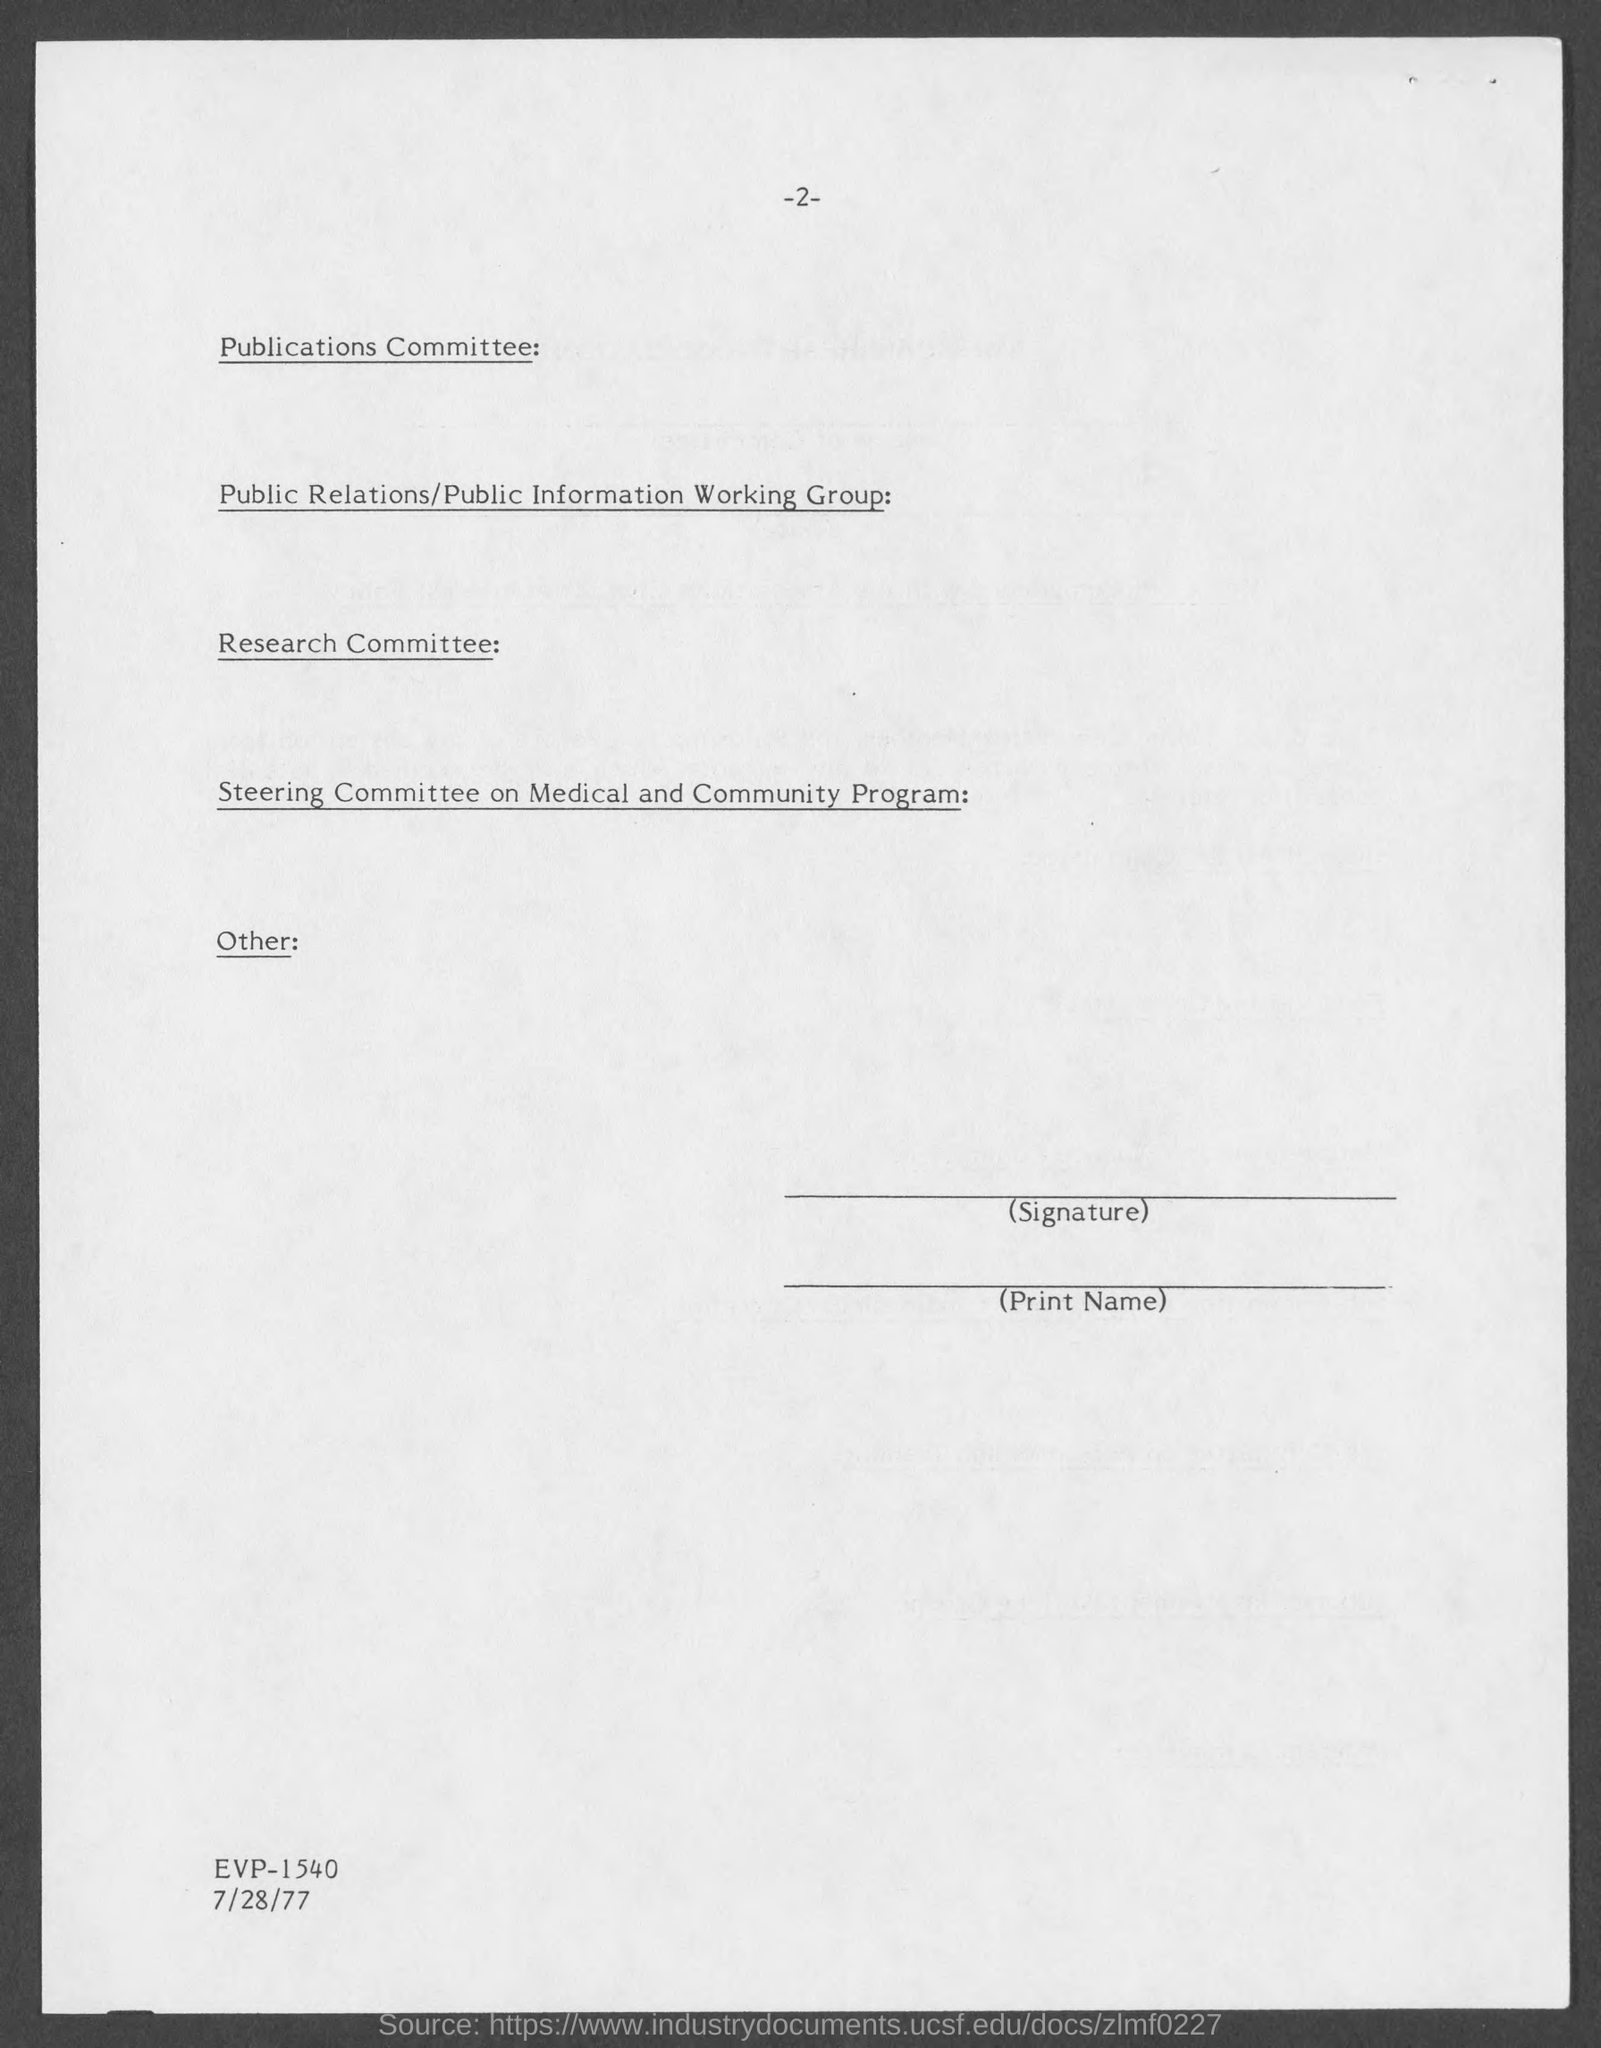Mention a couple of crucial points in this snapshot. The page number of this document is -2-. The date is 7/28/77. 